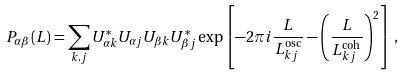Convert formula to latex. <formula><loc_0><loc_0><loc_500><loc_500>P _ { \alpha \beta } ( L ) = \sum _ { k , j } U _ { \alpha k } ^ { * } U _ { \alpha j } U _ { \beta k } U _ { \beta j } ^ { * } \exp \left [ - 2 \pi i \frac { L } { L ^ { \text {osc} } _ { k j } } - \left ( \frac { L } { L ^ { \text {coh} } _ { k j } } \right ) ^ { 2 } \right ] \, ,</formula> 